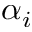Convert formula to latex. <formula><loc_0><loc_0><loc_500><loc_500>\alpha _ { i }</formula> 